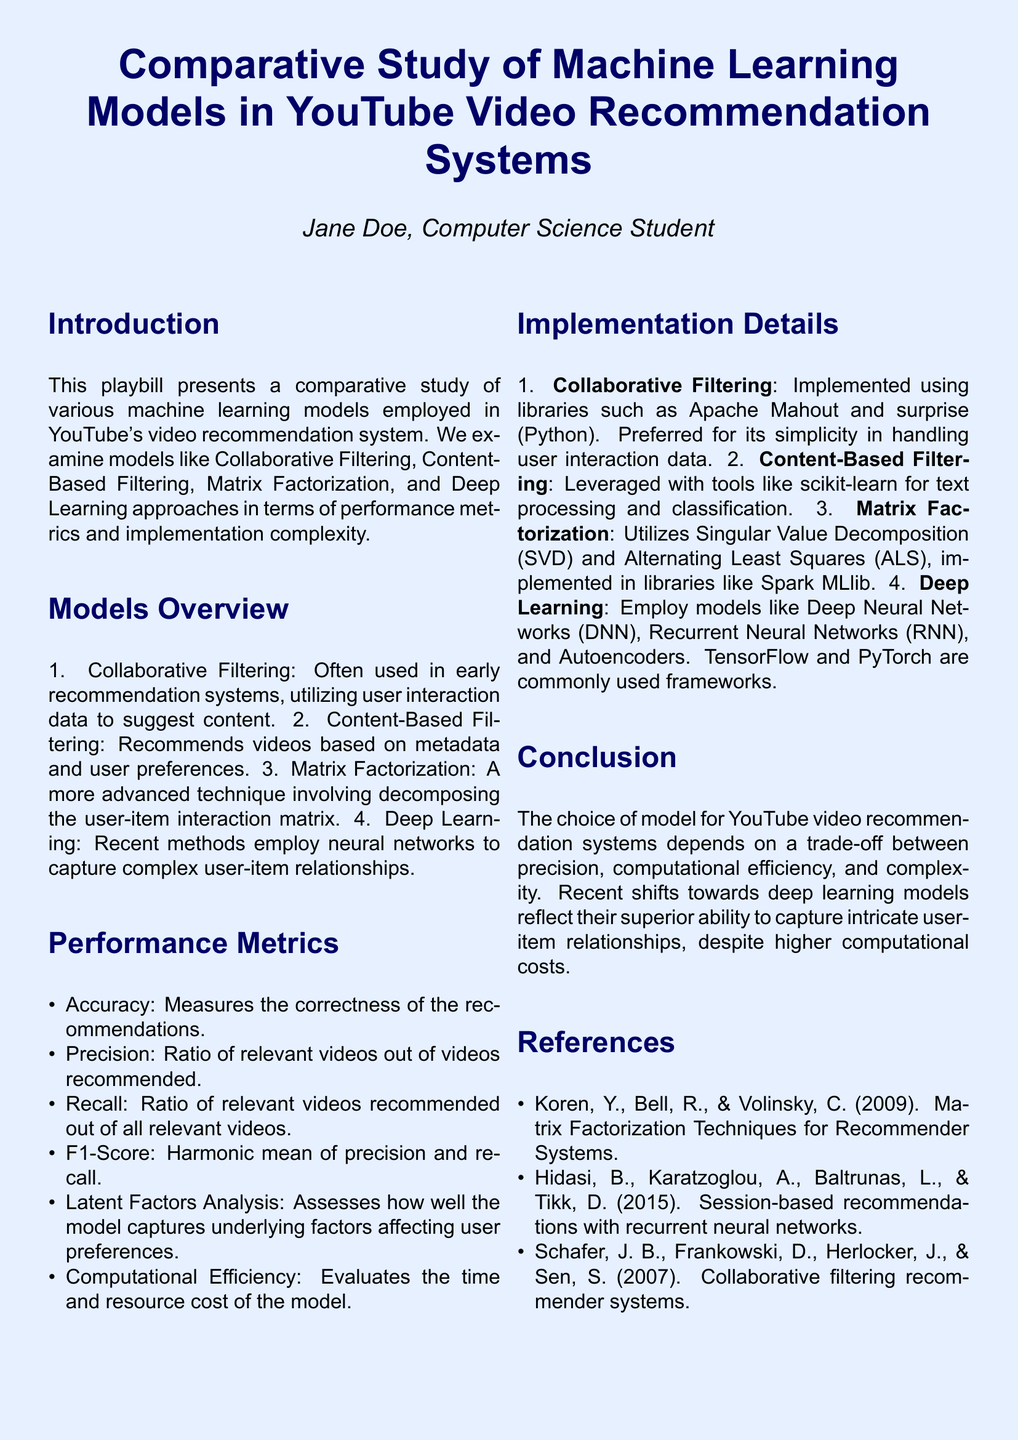What is the title of the study? The title of the study is presented at the beginning of the document as a central header.
Answer: Comparative Study of Machine Learning Models in YouTube Video Recommendation Systems Who is the author of the playbill? The author's name is stated below the title in italics.
Answer: Jane Doe What is one of the machine learning models mentioned? The document provides an overview of various models and lists them in the Models Overview section.
Answer: Collaborative Filtering What does F1-Score measure? The performance metrics section explains the purpose of various metrics.
Answer: Harmonic mean of precision and recall Which library is mentioned for implementing Deep Learning models? The Implementation Details section lists the libraries for each model type.
Answer: TensorFlow What technique does Matrix Factorization utilize? The discussion on Matrix Factorization mentions specific mathematical or algorithmic techniques used in its implementation.
Answer: Singular Value Decomposition What is the main trade-off discussed in the conclusion? The conclusion summarizes the factors affecting the model choice in recommendation systems.
Answer: Precision, computational efficiency, and complexity Which metric assesses user preferences' underlying factors? The performance metrics section defines the specific metrics used for evaluation.
Answer: Latent Factors Analysis What type of filtering is best for handling metadata? The Models Overview explains the strengths of the various filtering approaches.
Answer: Content-Based Filtering 